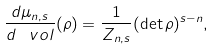<formula> <loc_0><loc_0><loc_500><loc_500>\frac { d \mu _ { n , s } } { d \, \ v o l } ( \rho ) = \frac { 1 } { Z _ { n , s } } ( \det \rho ) ^ { s - n } ,</formula> 